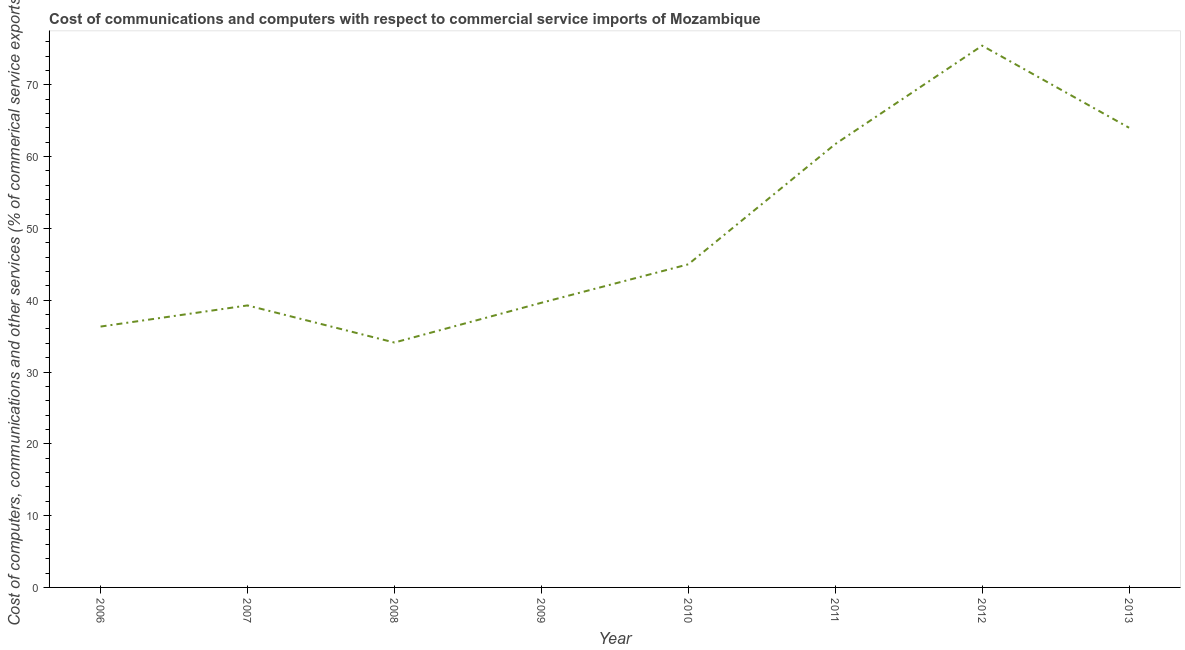What is the  computer and other services in 2007?
Your answer should be very brief. 39.27. Across all years, what is the maximum  computer and other services?
Offer a very short reply. 75.45. Across all years, what is the minimum  computer and other services?
Provide a short and direct response. 34.11. What is the sum of the  computer and other services?
Your answer should be compact. 395.56. What is the difference between the cost of communications in 2008 and 2010?
Your answer should be compact. -10.89. What is the average  computer and other services per year?
Provide a short and direct response. 49.44. What is the median cost of communications?
Ensure brevity in your answer.  42.32. What is the ratio of the cost of communications in 2006 to that in 2008?
Make the answer very short. 1.07. Is the cost of communications in 2007 less than that in 2011?
Your answer should be compact. Yes. Is the difference between the cost of communications in 2012 and 2013 greater than the difference between any two years?
Your response must be concise. No. What is the difference between the highest and the second highest cost of communications?
Offer a very short reply. 11.43. Is the sum of the  computer and other services in 2006 and 2013 greater than the maximum  computer and other services across all years?
Make the answer very short. Yes. What is the difference between the highest and the lowest  computer and other services?
Provide a short and direct response. 41.34. How many years are there in the graph?
Provide a succinct answer. 8. What is the difference between two consecutive major ticks on the Y-axis?
Provide a succinct answer. 10. Does the graph contain any zero values?
Your answer should be very brief. No. What is the title of the graph?
Keep it short and to the point. Cost of communications and computers with respect to commercial service imports of Mozambique. What is the label or title of the Y-axis?
Provide a short and direct response. Cost of computers, communications and other services (% of commerical service exports). What is the Cost of computers, communications and other services (% of commerical service exports) of 2006?
Your answer should be very brief. 36.33. What is the Cost of computers, communications and other services (% of commerical service exports) of 2007?
Provide a succinct answer. 39.27. What is the Cost of computers, communications and other services (% of commerical service exports) of 2008?
Ensure brevity in your answer.  34.11. What is the Cost of computers, communications and other services (% of commerical service exports) in 2009?
Keep it short and to the point. 39.64. What is the Cost of computers, communications and other services (% of commerical service exports) of 2010?
Your response must be concise. 45. What is the Cost of computers, communications and other services (% of commerical service exports) of 2011?
Provide a short and direct response. 61.74. What is the Cost of computers, communications and other services (% of commerical service exports) in 2012?
Ensure brevity in your answer.  75.45. What is the Cost of computers, communications and other services (% of commerical service exports) of 2013?
Offer a terse response. 64.02. What is the difference between the Cost of computers, communications and other services (% of commerical service exports) in 2006 and 2007?
Give a very brief answer. -2.94. What is the difference between the Cost of computers, communications and other services (% of commerical service exports) in 2006 and 2008?
Make the answer very short. 2.22. What is the difference between the Cost of computers, communications and other services (% of commerical service exports) in 2006 and 2009?
Offer a very short reply. -3.31. What is the difference between the Cost of computers, communications and other services (% of commerical service exports) in 2006 and 2010?
Ensure brevity in your answer.  -8.67. What is the difference between the Cost of computers, communications and other services (% of commerical service exports) in 2006 and 2011?
Make the answer very short. -25.41. What is the difference between the Cost of computers, communications and other services (% of commerical service exports) in 2006 and 2012?
Make the answer very short. -39.12. What is the difference between the Cost of computers, communications and other services (% of commerical service exports) in 2006 and 2013?
Your answer should be very brief. -27.69. What is the difference between the Cost of computers, communications and other services (% of commerical service exports) in 2007 and 2008?
Ensure brevity in your answer.  5.17. What is the difference between the Cost of computers, communications and other services (% of commerical service exports) in 2007 and 2009?
Make the answer very short. -0.37. What is the difference between the Cost of computers, communications and other services (% of commerical service exports) in 2007 and 2010?
Provide a succinct answer. -5.73. What is the difference between the Cost of computers, communications and other services (% of commerical service exports) in 2007 and 2011?
Provide a succinct answer. -22.47. What is the difference between the Cost of computers, communications and other services (% of commerical service exports) in 2007 and 2012?
Your answer should be very brief. -36.18. What is the difference between the Cost of computers, communications and other services (% of commerical service exports) in 2007 and 2013?
Ensure brevity in your answer.  -24.75. What is the difference between the Cost of computers, communications and other services (% of commerical service exports) in 2008 and 2009?
Your answer should be compact. -5.54. What is the difference between the Cost of computers, communications and other services (% of commerical service exports) in 2008 and 2010?
Provide a succinct answer. -10.89. What is the difference between the Cost of computers, communications and other services (% of commerical service exports) in 2008 and 2011?
Give a very brief answer. -27.63. What is the difference between the Cost of computers, communications and other services (% of commerical service exports) in 2008 and 2012?
Provide a succinct answer. -41.34. What is the difference between the Cost of computers, communications and other services (% of commerical service exports) in 2008 and 2013?
Provide a short and direct response. -29.91. What is the difference between the Cost of computers, communications and other services (% of commerical service exports) in 2009 and 2010?
Keep it short and to the point. -5.36. What is the difference between the Cost of computers, communications and other services (% of commerical service exports) in 2009 and 2011?
Your answer should be very brief. -22.1. What is the difference between the Cost of computers, communications and other services (% of commerical service exports) in 2009 and 2012?
Give a very brief answer. -35.81. What is the difference between the Cost of computers, communications and other services (% of commerical service exports) in 2009 and 2013?
Your answer should be very brief. -24.38. What is the difference between the Cost of computers, communications and other services (% of commerical service exports) in 2010 and 2011?
Keep it short and to the point. -16.74. What is the difference between the Cost of computers, communications and other services (% of commerical service exports) in 2010 and 2012?
Ensure brevity in your answer.  -30.45. What is the difference between the Cost of computers, communications and other services (% of commerical service exports) in 2010 and 2013?
Provide a succinct answer. -19.02. What is the difference between the Cost of computers, communications and other services (% of commerical service exports) in 2011 and 2012?
Provide a succinct answer. -13.71. What is the difference between the Cost of computers, communications and other services (% of commerical service exports) in 2011 and 2013?
Provide a short and direct response. -2.28. What is the difference between the Cost of computers, communications and other services (% of commerical service exports) in 2012 and 2013?
Give a very brief answer. 11.43. What is the ratio of the Cost of computers, communications and other services (% of commerical service exports) in 2006 to that in 2007?
Give a very brief answer. 0.93. What is the ratio of the Cost of computers, communications and other services (% of commerical service exports) in 2006 to that in 2008?
Offer a very short reply. 1.06. What is the ratio of the Cost of computers, communications and other services (% of commerical service exports) in 2006 to that in 2009?
Keep it short and to the point. 0.92. What is the ratio of the Cost of computers, communications and other services (% of commerical service exports) in 2006 to that in 2010?
Keep it short and to the point. 0.81. What is the ratio of the Cost of computers, communications and other services (% of commerical service exports) in 2006 to that in 2011?
Offer a terse response. 0.59. What is the ratio of the Cost of computers, communications and other services (% of commerical service exports) in 2006 to that in 2012?
Give a very brief answer. 0.48. What is the ratio of the Cost of computers, communications and other services (% of commerical service exports) in 2006 to that in 2013?
Provide a short and direct response. 0.57. What is the ratio of the Cost of computers, communications and other services (% of commerical service exports) in 2007 to that in 2008?
Ensure brevity in your answer.  1.15. What is the ratio of the Cost of computers, communications and other services (% of commerical service exports) in 2007 to that in 2010?
Provide a short and direct response. 0.87. What is the ratio of the Cost of computers, communications and other services (% of commerical service exports) in 2007 to that in 2011?
Ensure brevity in your answer.  0.64. What is the ratio of the Cost of computers, communications and other services (% of commerical service exports) in 2007 to that in 2012?
Keep it short and to the point. 0.52. What is the ratio of the Cost of computers, communications and other services (% of commerical service exports) in 2007 to that in 2013?
Your response must be concise. 0.61. What is the ratio of the Cost of computers, communications and other services (% of commerical service exports) in 2008 to that in 2009?
Provide a short and direct response. 0.86. What is the ratio of the Cost of computers, communications and other services (% of commerical service exports) in 2008 to that in 2010?
Offer a terse response. 0.76. What is the ratio of the Cost of computers, communications and other services (% of commerical service exports) in 2008 to that in 2011?
Provide a short and direct response. 0.55. What is the ratio of the Cost of computers, communications and other services (% of commerical service exports) in 2008 to that in 2012?
Provide a short and direct response. 0.45. What is the ratio of the Cost of computers, communications and other services (% of commerical service exports) in 2008 to that in 2013?
Your answer should be very brief. 0.53. What is the ratio of the Cost of computers, communications and other services (% of commerical service exports) in 2009 to that in 2010?
Offer a very short reply. 0.88. What is the ratio of the Cost of computers, communications and other services (% of commerical service exports) in 2009 to that in 2011?
Ensure brevity in your answer.  0.64. What is the ratio of the Cost of computers, communications and other services (% of commerical service exports) in 2009 to that in 2012?
Give a very brief answer. 0.53. What is the ratio of the Cost of computers, communications and other services (% of commerical service exports) in 2009 to that in 2013?
Your answer should be compact. 0.62. What is the ratio of the Cost of computers, communications and other services (% of commerical service exports) in 2010 to that in 2011?
Ensure brevity in your answer.  0.73. What is the ratio of the Cost of computers, communications and other services (% of commerical service exports) in 2010 to that in 2012?
Make the answer very short. 0.6. What is the ratio of the Cost of computers, communications and other services (% of commerical service exports) in 2010 to that in 2013?
Your response must be concise. 0.7. What is the ratio of the Cost of computers, communications and other services (% of commerical service exports) in 2011 to that in 2012?
Offer a terse response. 0.82. What is the ratio of the Cost of computers, communications and other services (% of commerical service exports) in 2011 to that in 2013?
Provide a short and direct response. 0.96. What is the ratio of the Cost of computers, communications and other services (% of commerical service exports) in 2012 to that in 2013?
Your answer should be compact. 1.18. 